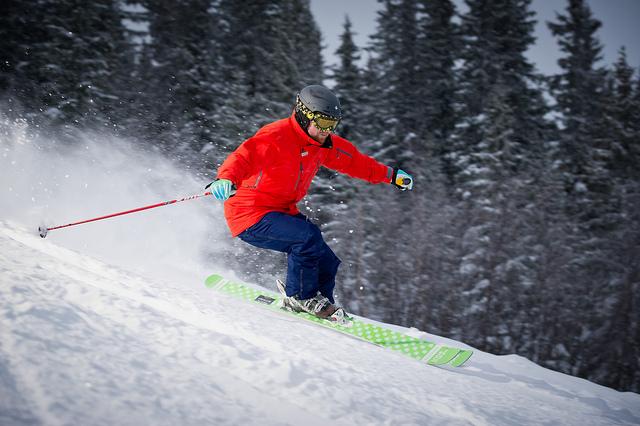What is the color of the skier's jacket?
Concise answer only. Red. Is the person going downhill?
Write a very short answer. Yes. Are the trees covered with snow?
Concise answer only. Yes. 